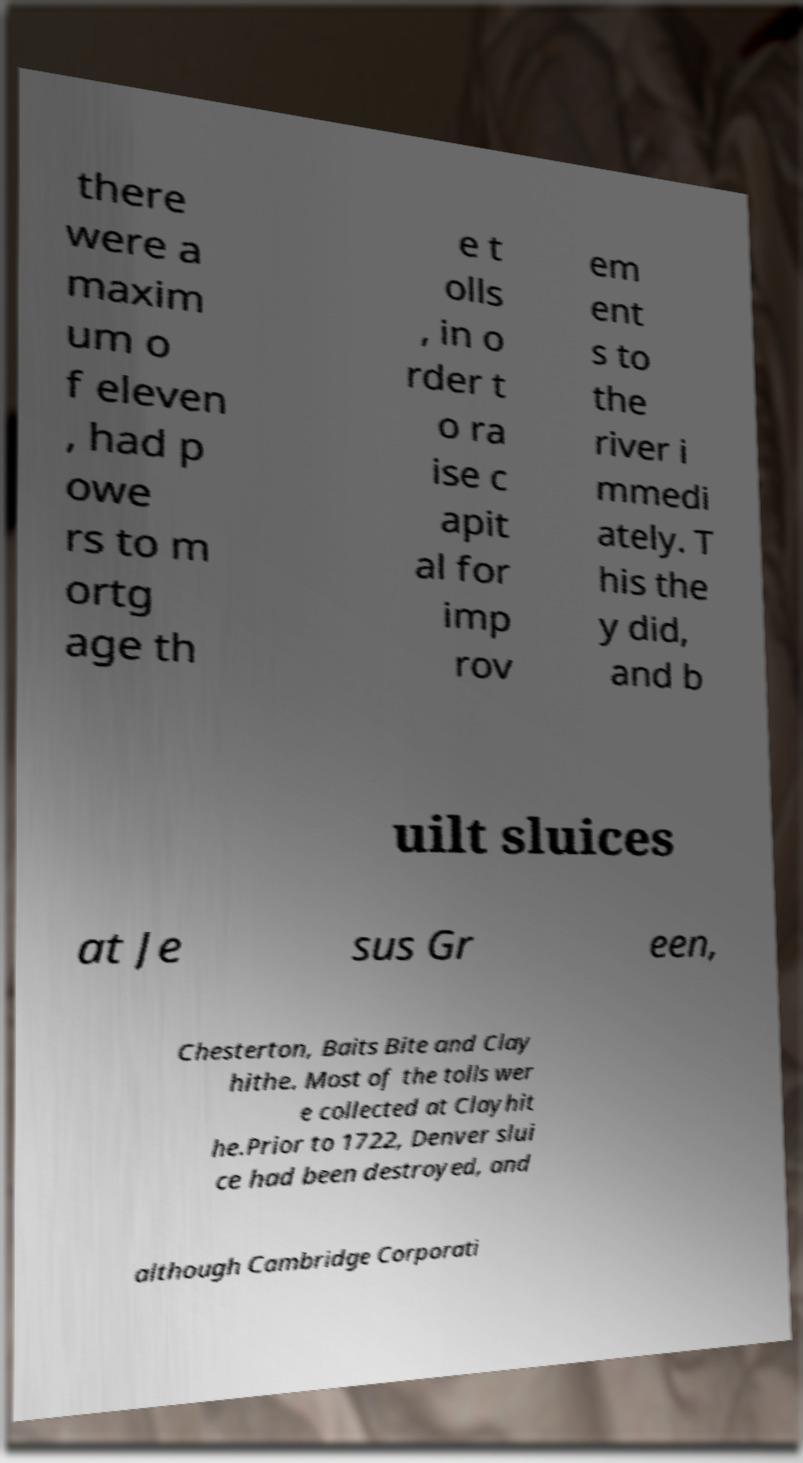Can you accurately transcribe the text from the provided image for me? there were a maxim um o f eleven , had p owe rs to m ortg age th e t olls , in o rder t o ra ise c apit al for imp rov em ent s to the river i mmedi ately. T his the y did, and b uilt sluices at Je sus Gr een, Chesterton, Baits Bite and Clay hithe. Most of the tolls wer e collected at Clayhit he.Prior to 1722, Denver slui ce had been destroyed, and although Cambridge Corporati 